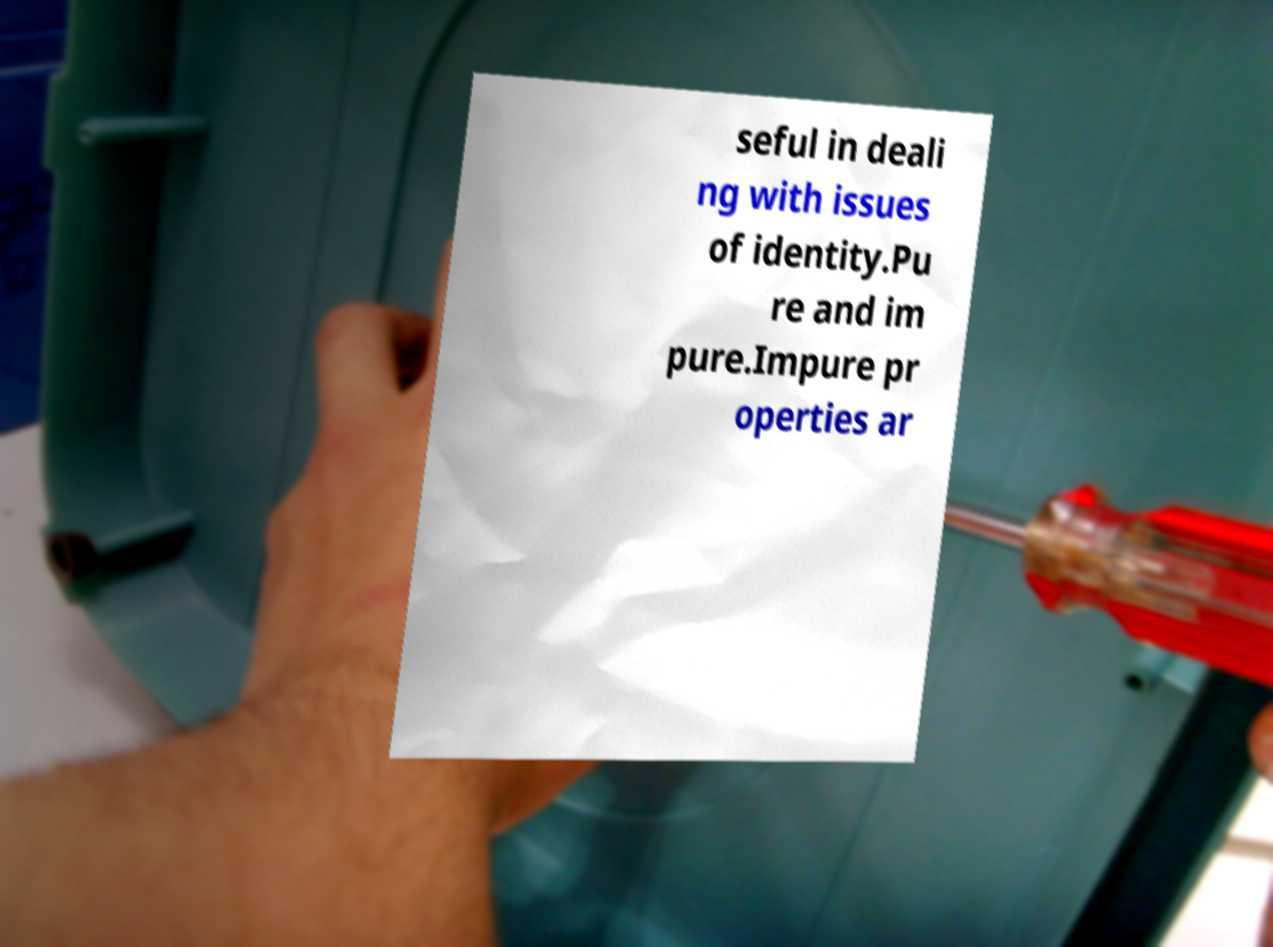What messages or text are displayed in this image? I need them in a readable, typed format. seful in deali ng with issues of identity.Pu re and im pure.Impure pr operties ar 